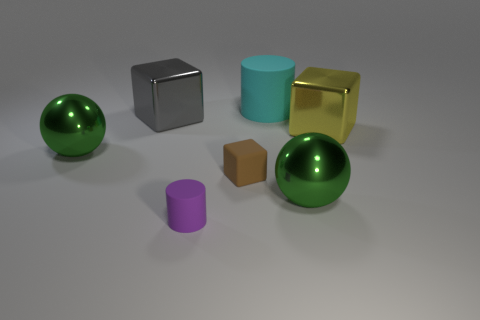What shape is the big metallic thing behind the metal block in front of the gray shiny object?
Provide a succinct answer. Cube. What is the material of the other thing that is the same shape as the tiny purple matte object?
Make the answer very short. Rubber. The block that is the same size as the purple rubber cylinder is what color?
Your response must be concise. Brown. Are there an equal number of green balls behind the gray thing and yellow objects?
Keep it short and to the point. No. What is the color of the rubber thing that is in front of the sphere right of the tiny brown rubber object?
Offer a terse response. Purple. There is a green thing that is to the right of the large gray metal block in front of the big cyan rubber object; what size is it?
Give a very brief answer. Large. What number of other things are the same size as the brown rubber object?
Ensure brevity in your answer.  1. What color is the sphere that is on the left side of the green shiny object on the right side of the large cube behind the big yellow block?
Offer a very short reply. Green. How many other things are there of the same shape as the yellow metallic object?
Offer a very short reply. 2. What is the shape of the large green metallic thing that is right of the brown matte block?
Offer a terse response. Sphere. 